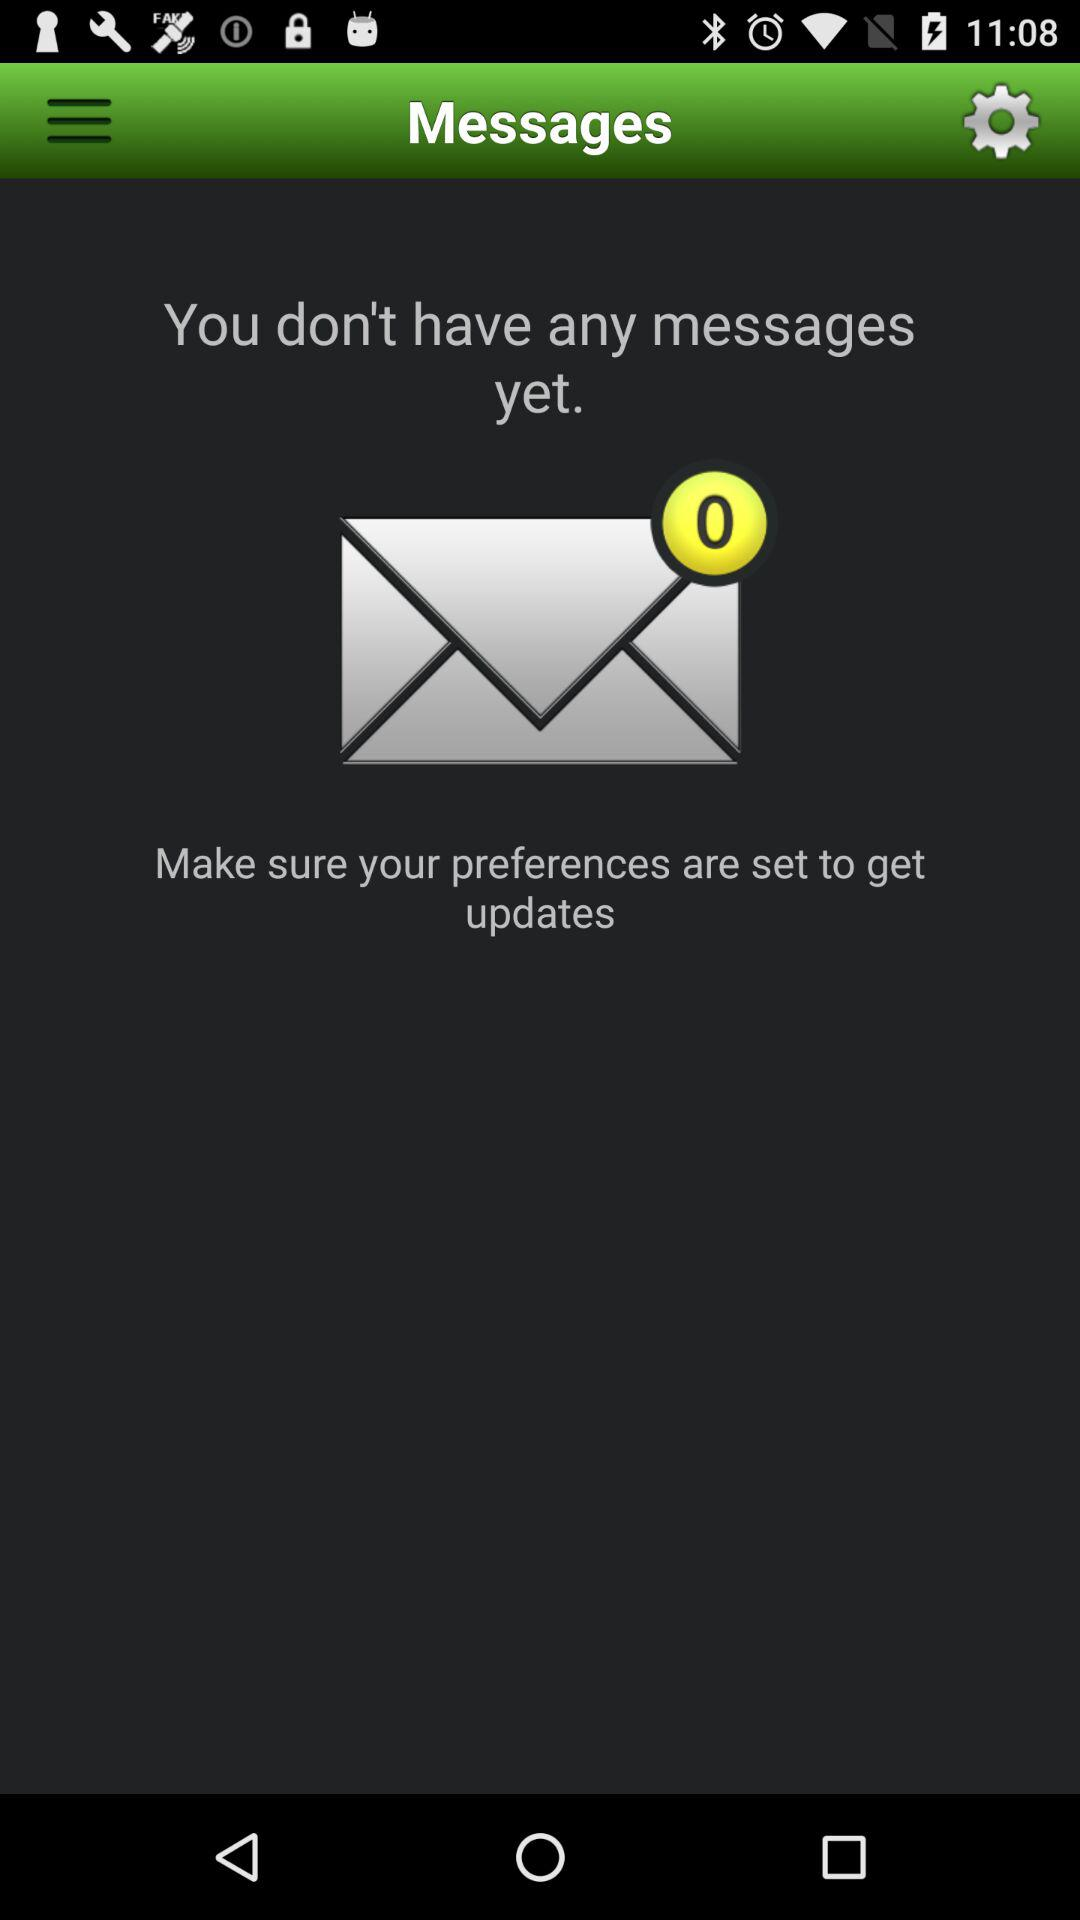What is the application name? The application name is "Messages". 